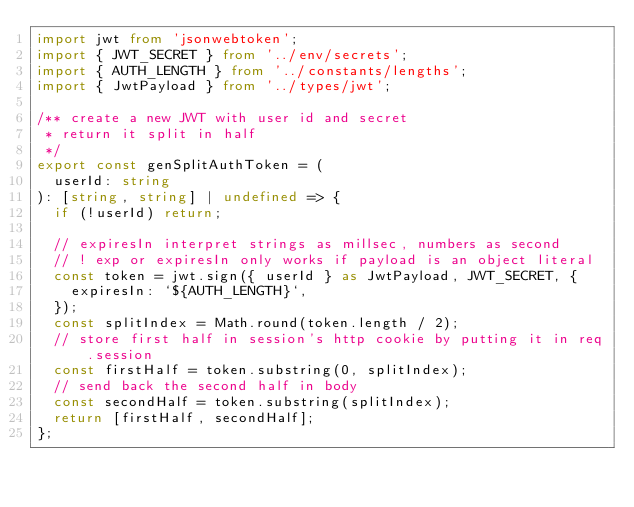Convert code to text. <code><loc_0><loc_0><loc_500><loc_500><_TypeScript_>import jwt from 'jsonwebtoken';
import { JWT_SECRET } from '../env/secrets';
import { AUTH_LENGTH } from '../constants/lengths';
import { JwtPayload } from '../types/jwt';

/** create a new JWT with user id and secret
 * return it split in half
 */
export const genSplitAuthToken = (
  userId: string
): [string, string] | undefined => {
  if (!userId) return;

  // expiresIn interpret strings as millsec, numbers as second
  // ! exp or expiresIn only works if payload is an object literal
  const token = jwt.sign({ userId } as JwtPayload, JWT_SECRET, {
    expiresIn: `${AUTH_LENGTH}`,
  });
  const splitIndex = Math.round(token.length / 2);
  // store first half in session's http cookie by putting it in req.session
  const firstHalf = token.substring(0, splitIndex);
  // send back the second half in body
  const secondHalf = token.substring(splitIndex);
  return [firstHalf, secondHalf];
};
</code> 